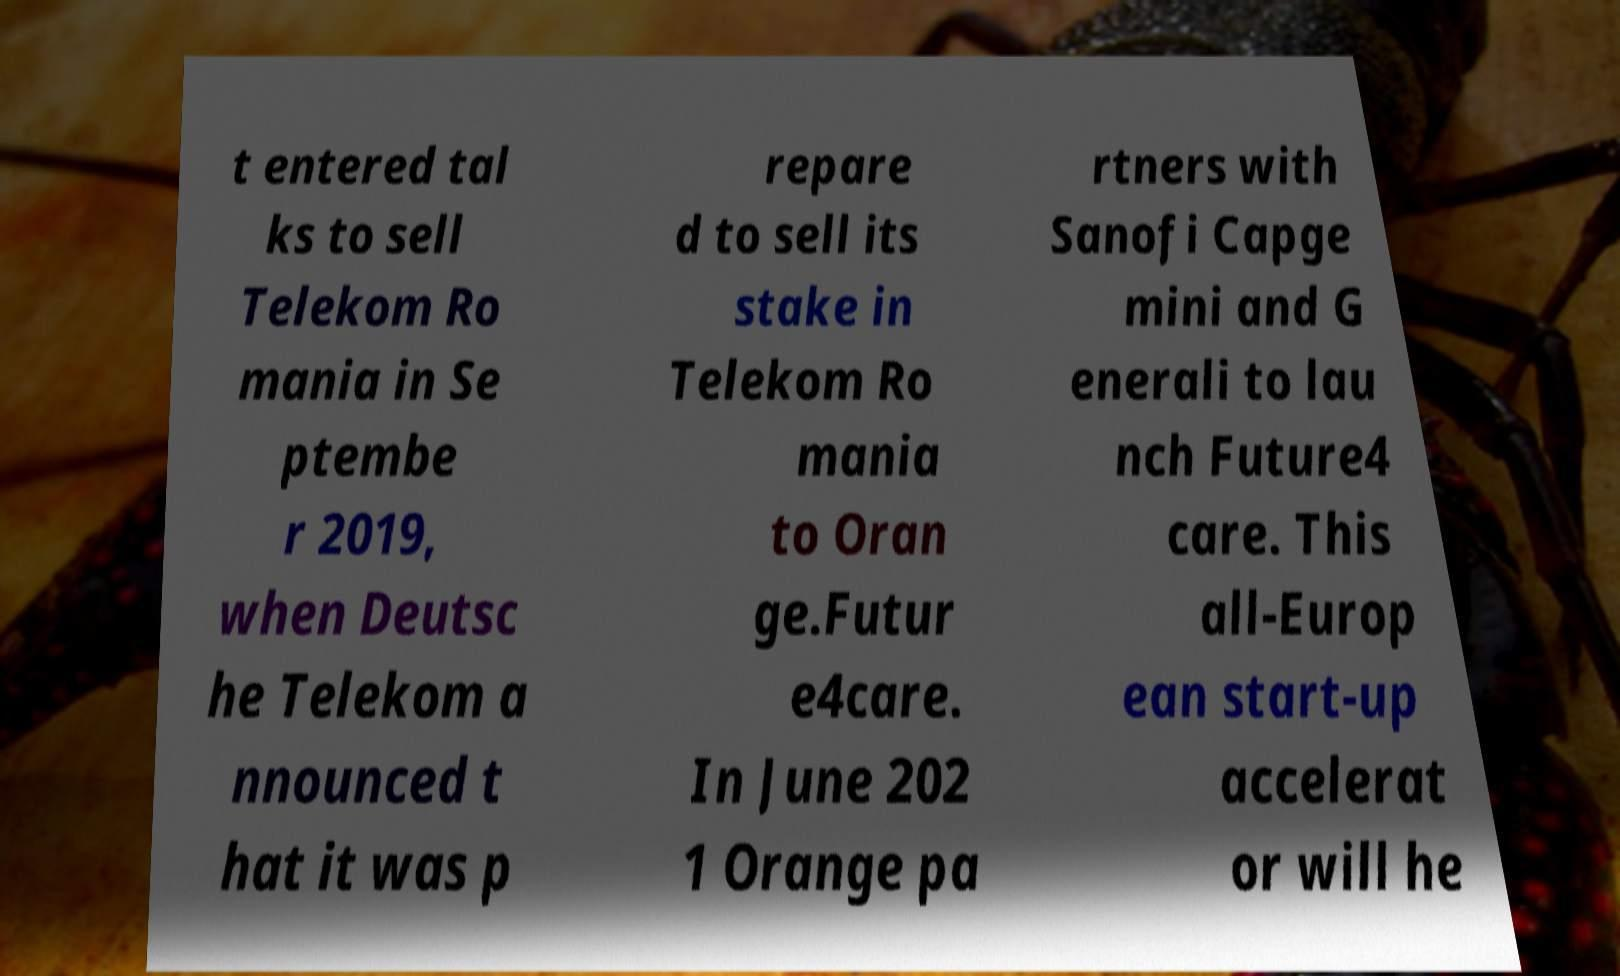Could you assist in decoding the text presented in this image and type it out clearly? t entered tal ks to sell Telekom Ro mania in Se ptembe r 2019, when Deutsc he Telekom a nnounced t hat it was p repare d to sell its stake in Telekom Ro mania to Oran ge.Futur e4care. In June 202 1 Orange pa rtners with Sanofi Capge mini and G enerali to lau nch Future4 care. This all-Europ ean start-up accelerat or will he 